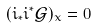<formula> <loc_0><loc_0><loc_500><loc_500>( i _ { * } i ^ { * } { \mathcal { G } } ) _ { x } = 0</formula> 